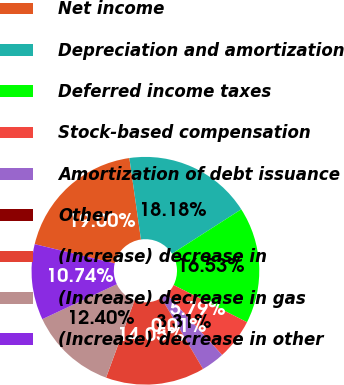<chart> <loc_0><loc_0><loc_500><loc_500><pie_chart><fcel>Net income<fcel>Depreciation and amortization<fcel>Deferred income taxes<fcel>Stock-based compensation<fcel>Amortization of debt issuance<fcel>Other<fcel>(Increase) decrease in<fcel>(Increase) decrease in gas<fcel>(Increase) decrease in other<nl><fcel>19.0%<fcel>18.18%<fcel>16.53%<fcel>5.79%<fcel>3.31%<fcel>0.01%<fcel>14.05%<fcel>12.4%<fcel>10.74%<nl></chart> 